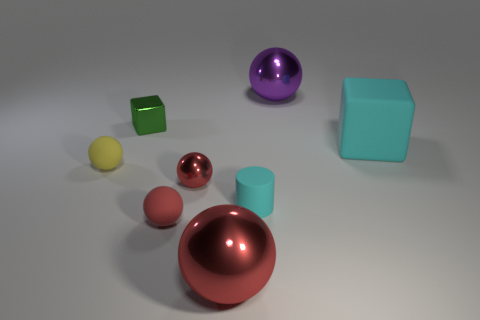Can you tell me how many objects there are in total? In total, there are seven objects displayed in the image, each varying in shape and color.  What can you tell me about the different finishes on the objects? The objects exhibit a mix of finishes; some, like the copper-colored sphere and the purple sphere, have a reflective glossy surface, whereas others like the cyan cube and the green smaller cube present a matte finish which absorbs light rather than reflecting it. 